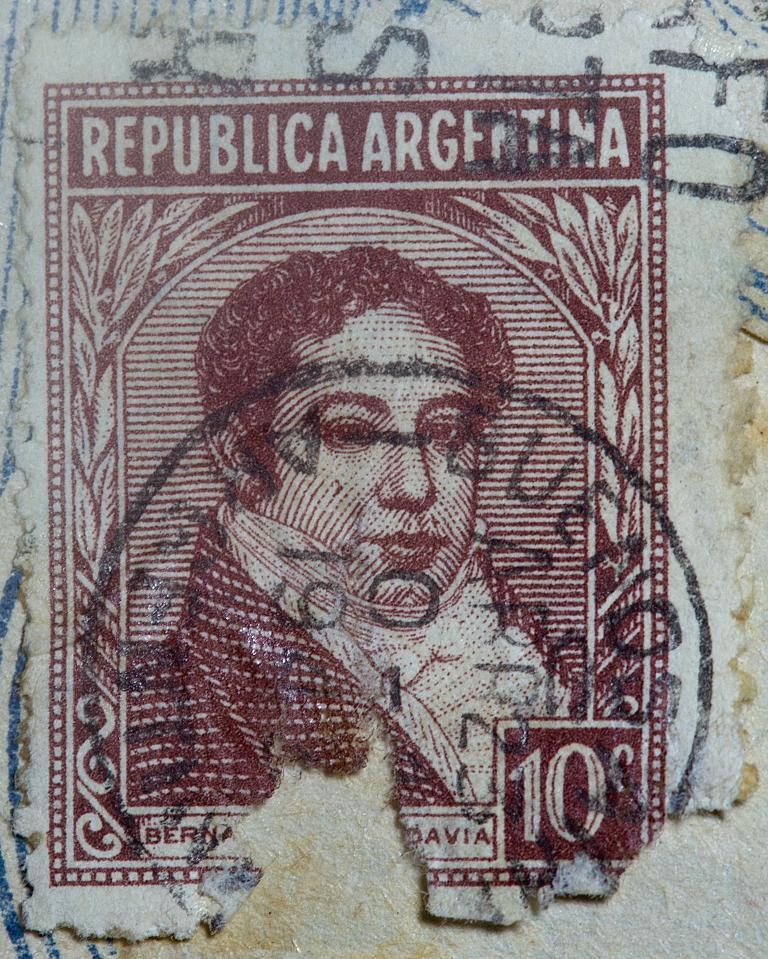What is present on the wall in the image? There is an image of a person and text on the wall. Can you describe the image of the person on the wall? Unfortunately, the details of the person's image cannot be determined from the provided facts. What type of information is conveyed by the text on the wall? The content of the text on the wall cannot be determined from the provided facts. Can you see any lakes or bodies of water in the image? There is no mention of a lake or body of water in the provided facts, so it cannot be determined if one is present in the image. What type of badge is being displayed on the wall in the image? There is no mention of a badge in the provided facts, so it cannot be determined if one is present in the image. 